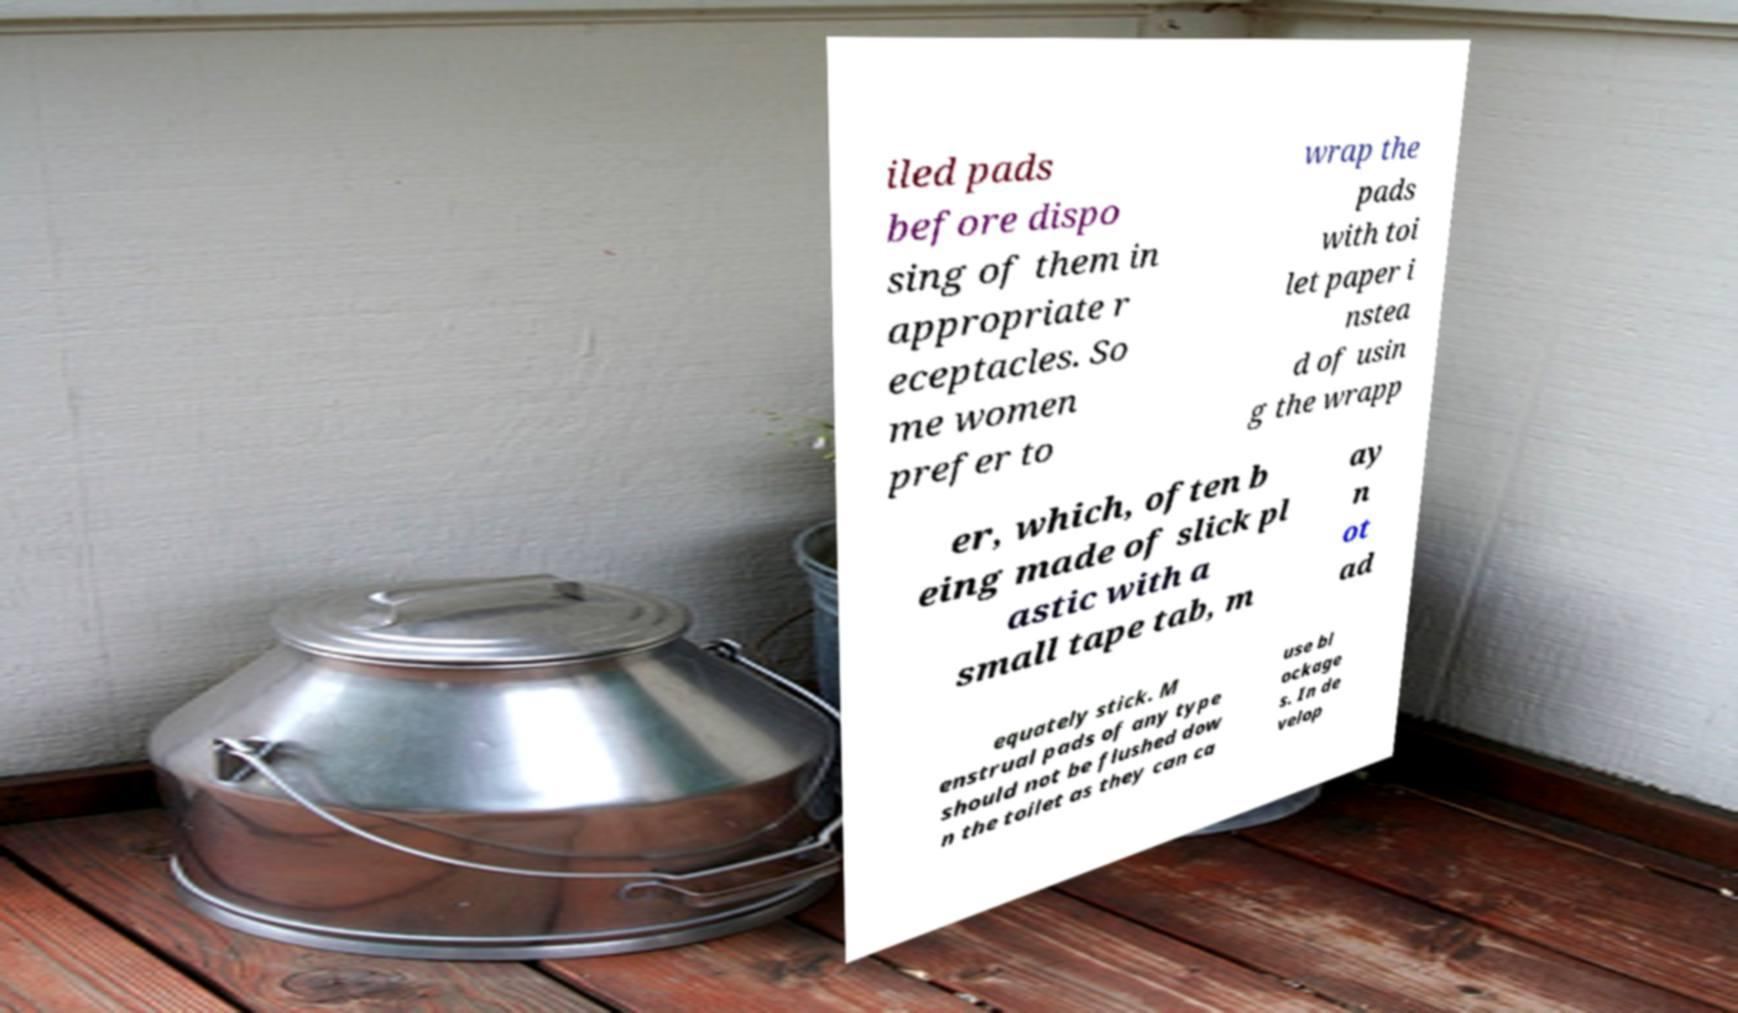Please read and relay the text visible in this image. What does it say? iled pads before dispo sing of them in appropriate r eceptacles. So me women prefer to wrap the pads with toi let paper i nstea d of usin g the wrapp er, which, often b eing made of slick pl astic with a small tape tab, m ay n ot ad equately stick. M enstrual pads of any type should not be flushed dow n the toilet as they can ca use bl ockage s. In de velop 